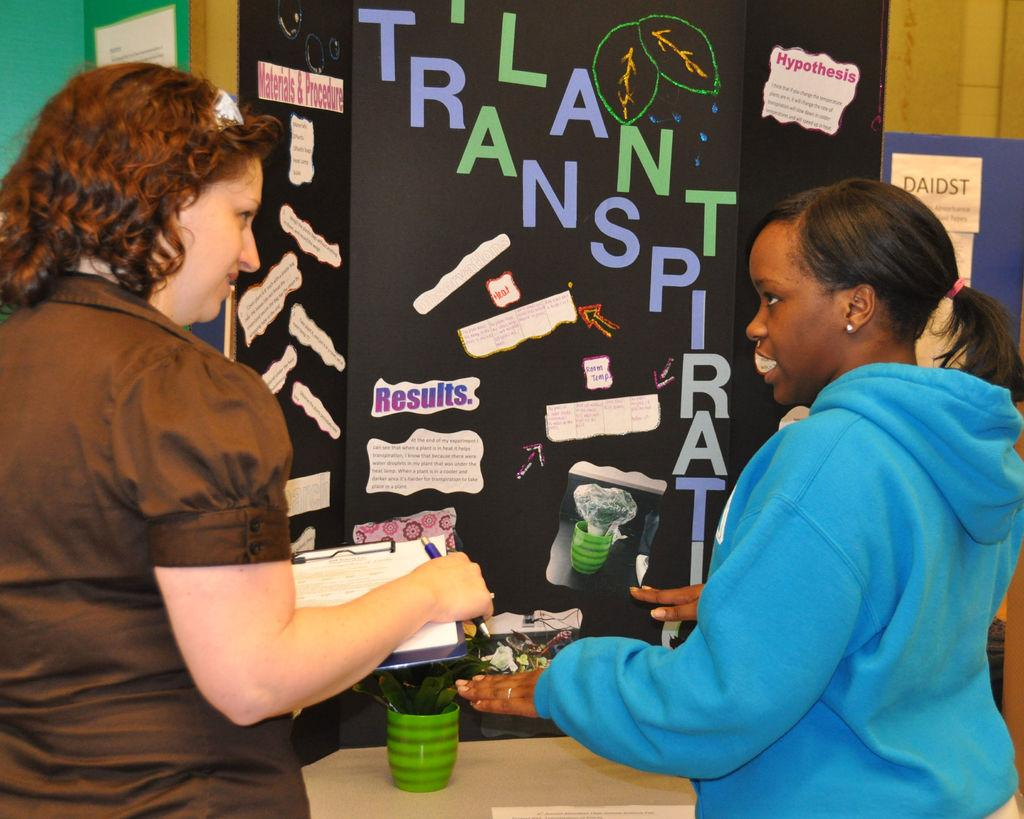What is the woman holding in the image? The woman is holding a pad, paper, and pen. Can you describe the other woman in the image? There is another woman standing in the image. What object can be seen in the image that might hold or store items? There is a container in the image. What type of decorative items are present in the image? There are posters in the image. How many balloons are being held by the woman in the image? There are no balloons present in the image. What type of cakes are being served at the event depicted in the image? There is no event or cakes depicted in the image. 